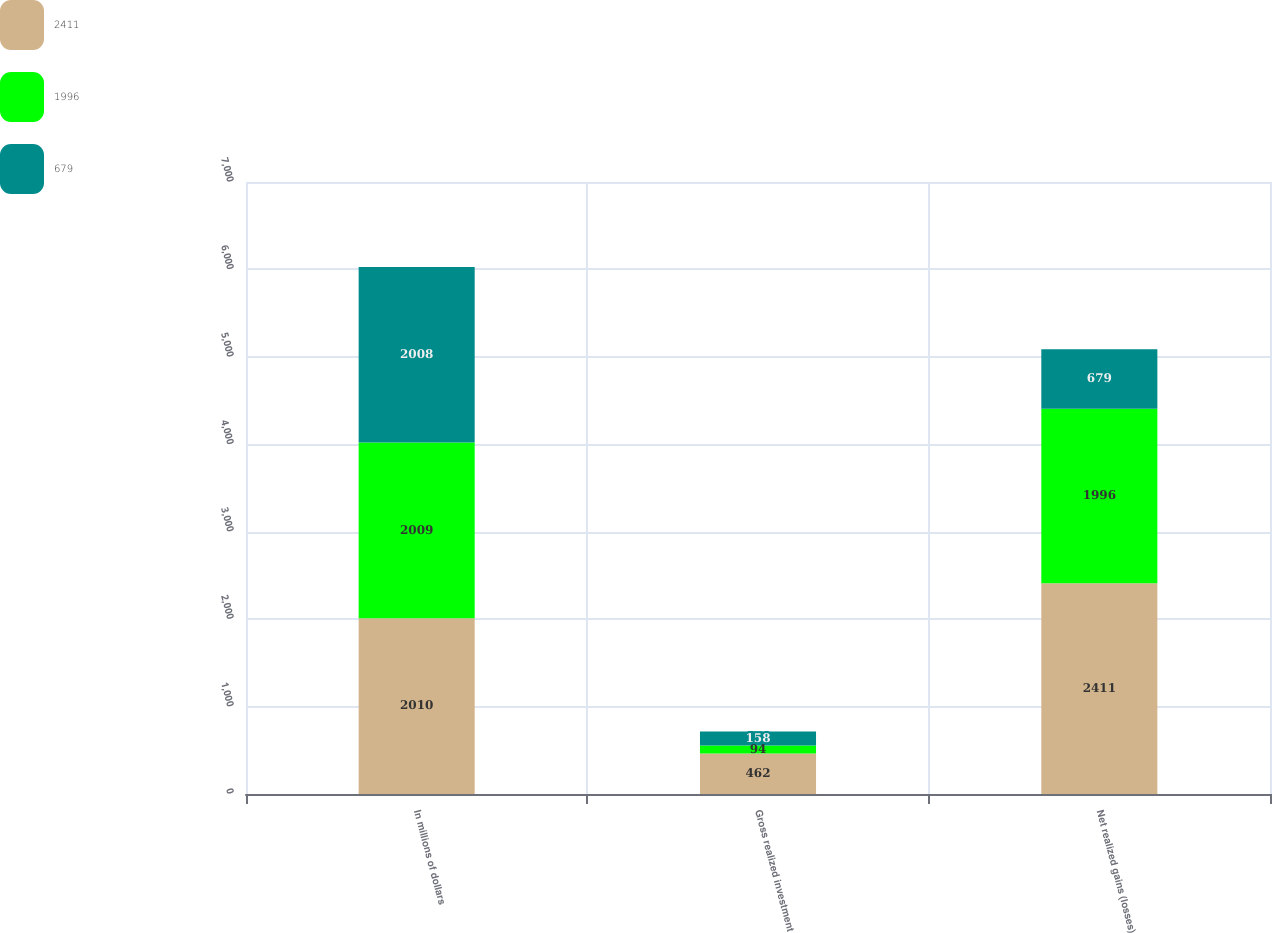Convert chart to OTSL. <chart><loc_0><loc_0><loc_500><loc_500><stacked_bar_chart><ecel><fcel>In millions of dollars<fcel>Gross realized investment<fcel>Net realized gains (losses)<nl><fcel>2411<fcel>2010<fcel>462<fcel>2411<nl><fcel>1996<fcel>2009<fcel>94<fcel>1996<nl><fcel>679<fcel>2008<fcel>158<fcel>679<nl></chart> 